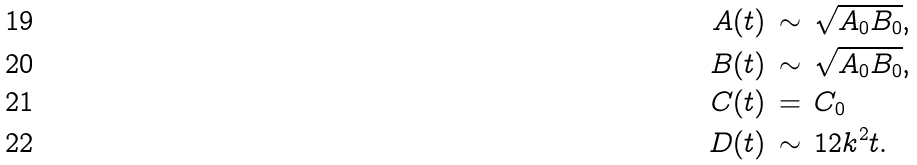<formula> <loc_0><loc_0><loc_500><loc_500>A ( t ) \, & \sim \, \sqrt { A _ { 0 } B _ { 0 } } , \\ B ( t ) \, & \sim \, \sqrt { A _ { 0 } B _ { 0 } } , \\ C ( t ) \, & = \, C _ { 0 } \\ D ( t ) \, & \sim \, 1 2 k ^ { 2 } t .</formula> 